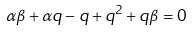Convert formula to latex. <formula><loc_0><loc_0><loc_500><loc_500>\alpha \beta + \alpha q - q + { q } ^ { 2 } + q \beta = 0</formula> 